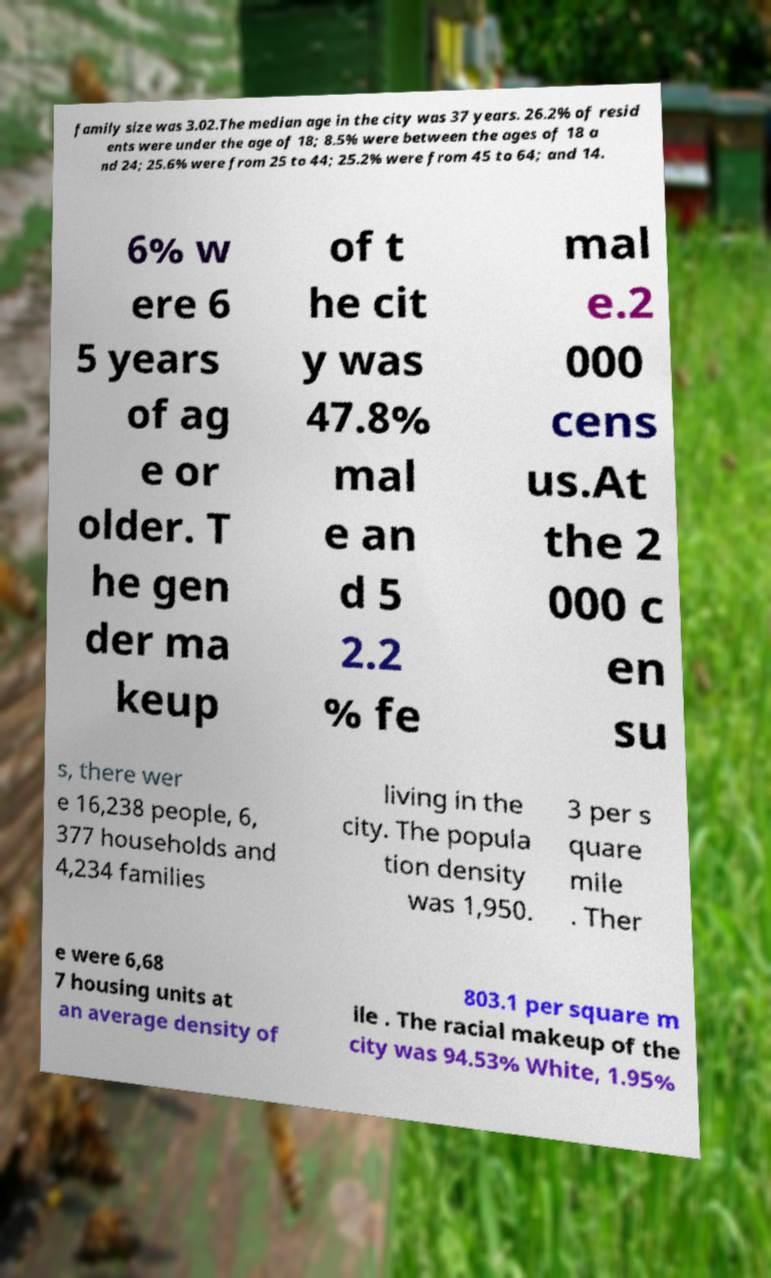Please identify and transcribe the text found in this image. family size was 3.02.The median age in the city was 37 years. 26.2% of resid ents were under the age of 18; 8.5% were between the ages of 18 a nd 24; 25.6% were from 25 to 44; 25.2% were from 45 to 64; and 14. 6% w ere 6 5 years of ag e or older. T he gen der ma keup of t he cit y was 47.8% mal e an d 5 2.2 % fe mal e.2 000 cens us.At the 2 000 c en su s, there wer e 16,238 people, 6, 377 households and 4,234 families living in the city. The popula tion density was 1,950. 3 per s quare mile . Ther e were 6,68 7 housing units at an average density of 803.1 per square m ile . The racial makeup of the city was 94.53% White, 1.95% 